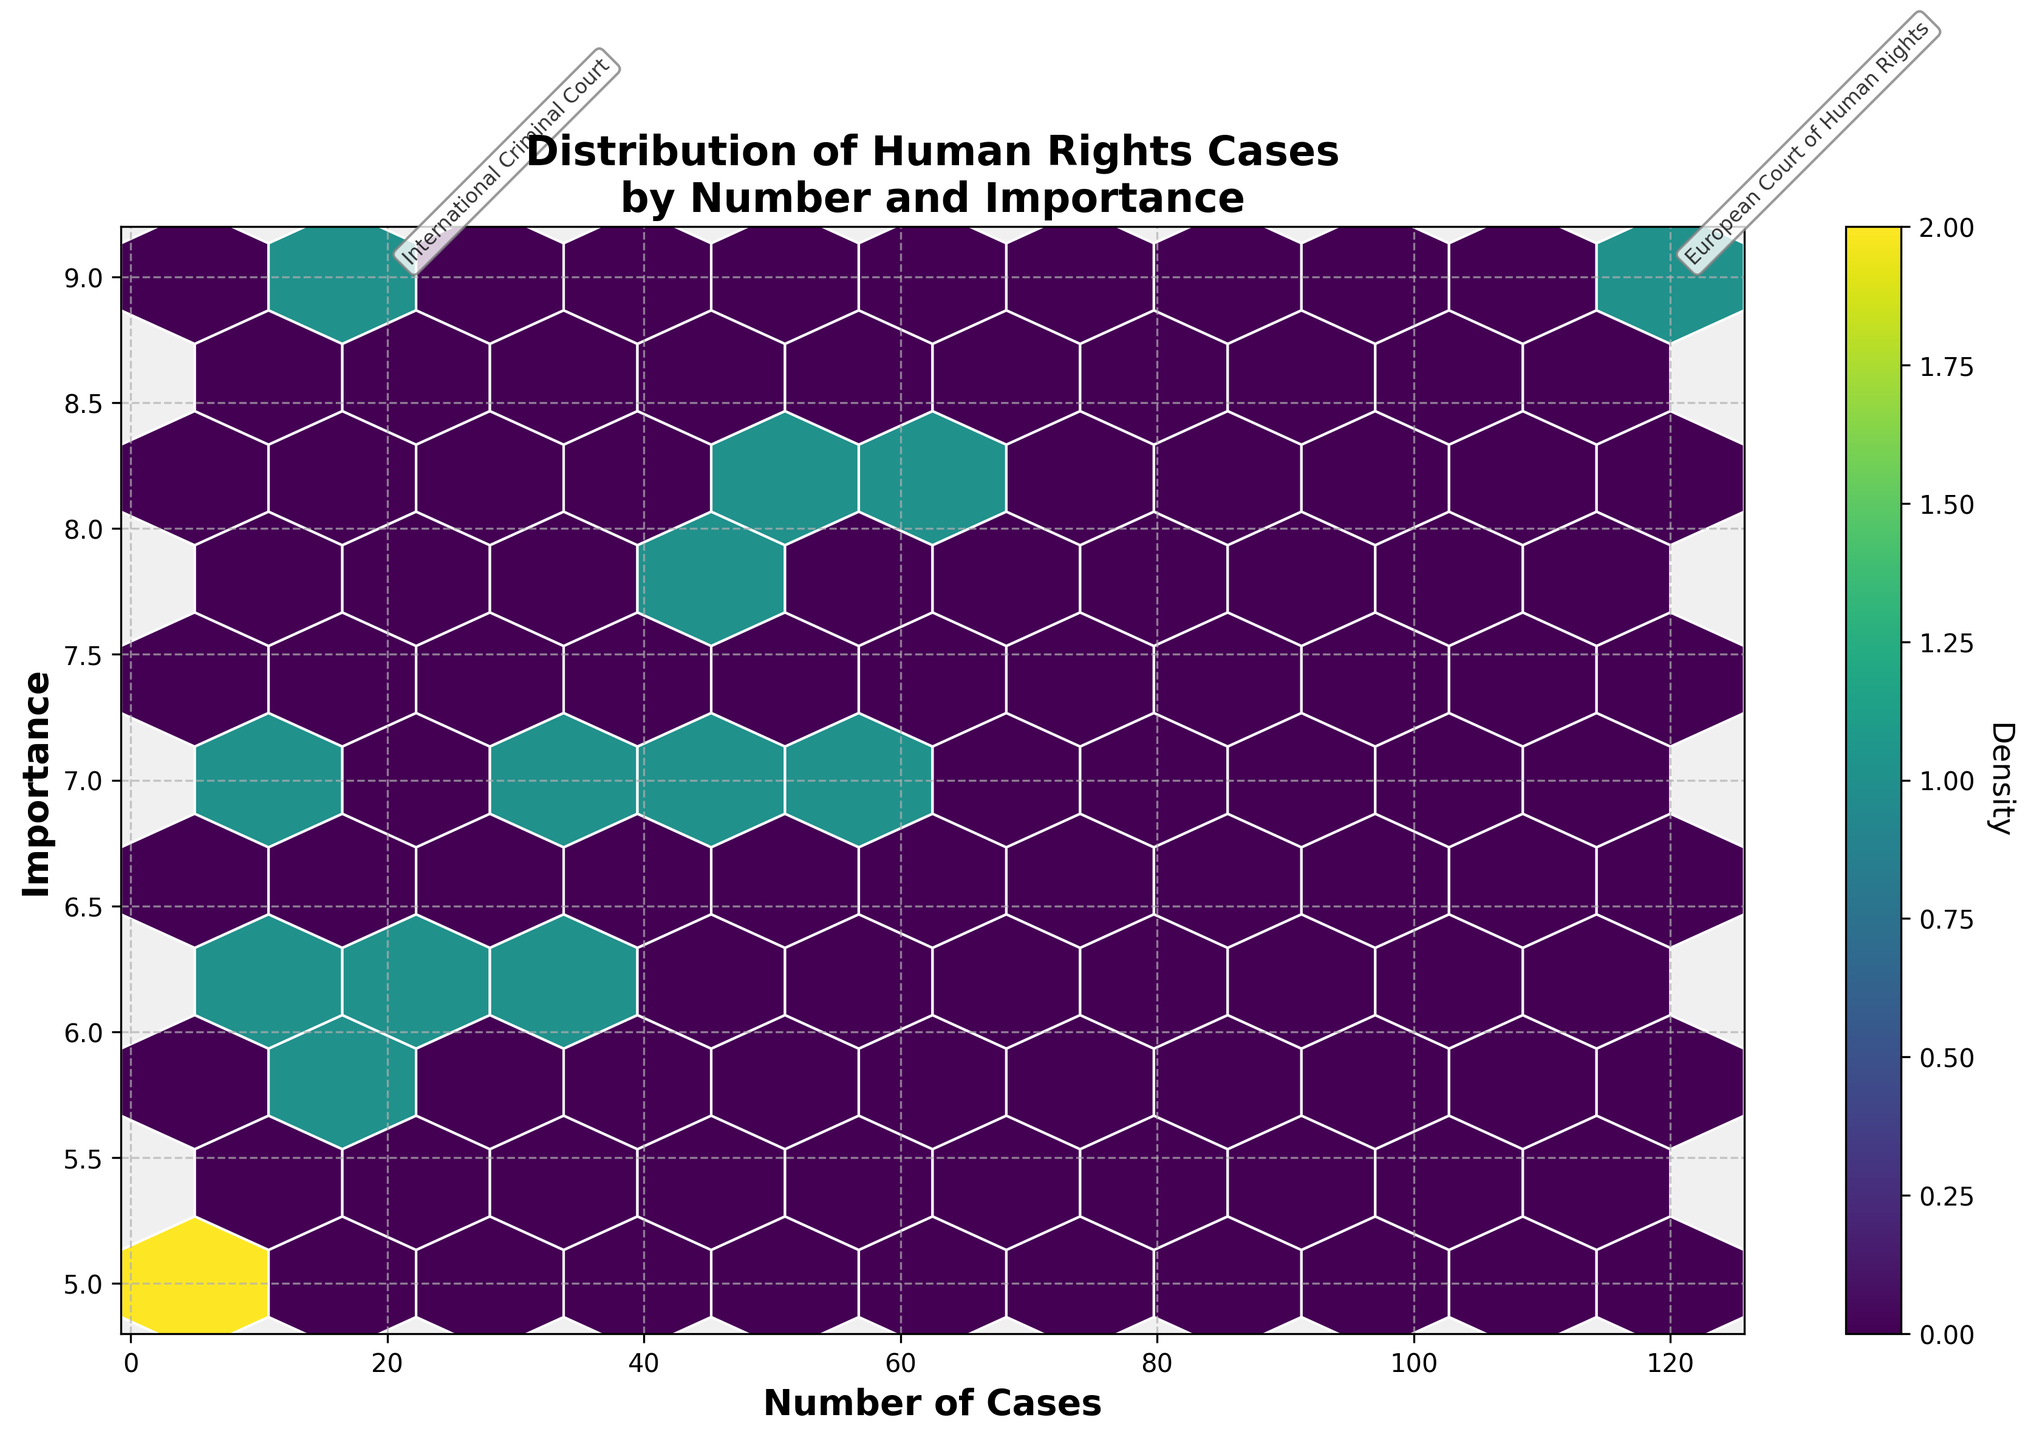What is the title of the plot? The title of the plot can be found at the top of the figure, often in larger font which provides a clear understanding of the subject of the plot. It reads: "Distribution of Human Rights Cases by Number and Importance".
Answer: Distribution of Human Rights Cases by Number and Importance How many cases does the European Court of Human Rights handle? The number of cases is indicated along the 'Number of Cases' axis. The European Court of Human Rights has a distinct annotation near the higher end of the 'Number of Cases' axis, indicating 120 cases.
Answer: 120 Which court has a combination of high importance and high number of cases? Courts with a high number of cases and high importance are usually annotated due to their significance. The European Court of Human Rights is both high on the 'Number of Cases' axis (120 cases) and near the highest 'Importance' value (9).
Answer: European Court of Human Rights How does the number of cases for the International Criminal Court compare to the UN Human Rights Committee? To compare, look at their annotations or positions on the 'Number of Cases' axis. The International Criminal Court has 20 cases while the UN Human Rights Committee has 60 cases.
Answer: The UN Human Rights Committee handles more cases than the International Criminal Court What is the range of importance values in the plot? The 'Importance' values can be observed along the vertical axis. The lowest recorded importance value is 5 (e.g., Special Tribunal for Lebanon) and the highest is 9 (e.g., International Criminal Court, European Court of Human Rights).
Answer: 5 to 9 Which court has the fewest number of cases? Observing the leftmost positions or the smallest values along the 'Number of Cases' axis, the Residual Special Court for Sierra Leone has the fewest cases with only 5.
Answer: Residual Special Court for Sierra Leone Between the Committee on the Rights of the Child and the Committee on the Elimination of Discrimination against Women, which one has a higher importance? By comparing their vertical positions in the plot, the Committee on the Elimination of Discrimination against Women has an importance of 8, whereas the Committee on the Rights of the Child has an importance of 7.
Answer: Committee on the Elimination of Discrimination against Women What is the density level in the plot, as indicated by the colorbar? The density of points is shown by varying colors in the hexbin plot, where the colorbar on the right side provides a key. The colors transition from lighter shades to darker ones, indicating increasing density, with denser regions showing more intensive colors as suggested by the colorbar.
Answer: Varies from light to dark shades indicating increasing density Is there any court with an importance of 5? Importance values of 5 are represented in lower positions on the 'Importance' axis. The Special Tribunal for Lebanon and Residual Special Court for Sierra Leone are two such courts, both with an importance value of 5.
Answer: Yes, Special Tribunal for Lebanon and Residual Special Court for Sierra Leone Which court has more cases, the African Court on Human and Peoples' Rights or the Inter-American Court of Human Rights? Comparing the number of cases indicated along the 'Number of Cases' axis reveals that the Inter-American Court of Human Rights has 30 cases whereas the African Court on Human and Peoples' Rights has 25 cases.
Answer: Inter-American Court of Human Rights 